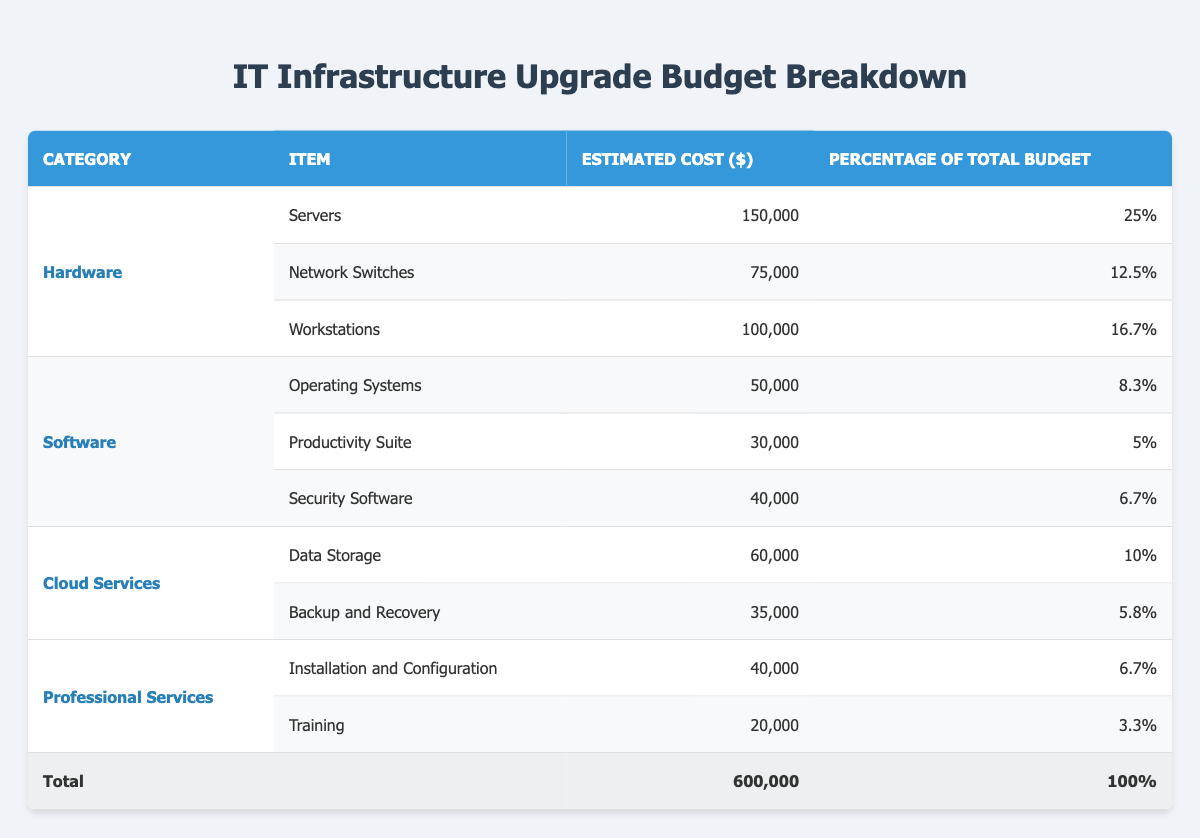What is the estimated cost of Workstations? The table shows a specific row under the Hardware category for Workstations with an estimated cost of 100,000 dollars. This value can be found directly in the table under the corresponding columns.
Answer: 100,000 What percentage of the total budget is allocated to Security Software? Looking at the Software category in the table, the item Security Software has an estimated percentage of 6.7% of the total budget. This percentage can be directly retrieved from the corresponding row.
Answer: 6.7% What is the total estimated cost for all Hardware items? To find the total cost for Hardware, add the estimated costs of Servers (150,000), Network Switches (75,000), and Workstations (100,000). The calculation is 150,000 + 75,000 + 100,000 = 325,000.
Answer: 325,000 Is the estimated cost for Backup and Recovery less than that for Operating Systems? The table lists the estimated cost for Backup and Recovery as 35,000 and for Operating Systems as 50,000. Since 35,000 is less than 50,000, the statement is true.
Answer: Yes What is the average estimated cost of items under the Professional Services category? The estimated costs for Installation and Configuration (40,000) and Training (20,000) under the Professional Services category need to be averaged. First, add them: 40,000 + 20,000 = 60,000. Then divide by 2 (the number of items): 60,000 / 2 = 30,000.
Answer: 30,000 What is the total budget allocated for Software items and how does it compare to the total budget? The total estimated cost for Software items can be calculated as the sum of Operating Systems (50,000), Productivity Suite (30,000), and Security Software (40,000), which is 50,000 + 30,000 + 40,000 = 120,000. Comparing this to the total budget of 600,000, Software items account for a smaller portion of the budget.
Answer: 120,000 How much more is spent on Hardware compared to Cloud Services? The total estimated cost for Hardware is 325,000, and for Cloud Services, it is the sum of Data Storage (60,000) and Backup and Recovery (35,000), which is 60,000 + 35,000 = 95,000. The difference is 325,000 - 95,000 = 230,000. This shows that more is spent on Hardware.
Answer: 230,000 Are there more Professional Services items than Cloud Services items listed in the table? The table lists two Professional Services items (Installation and Configuration and Training) and two Cloud Services items (Data Storage and Backup and Recovery). Since both categories have the same number of items, the answer is that there are not more in either category.
Answer: No 